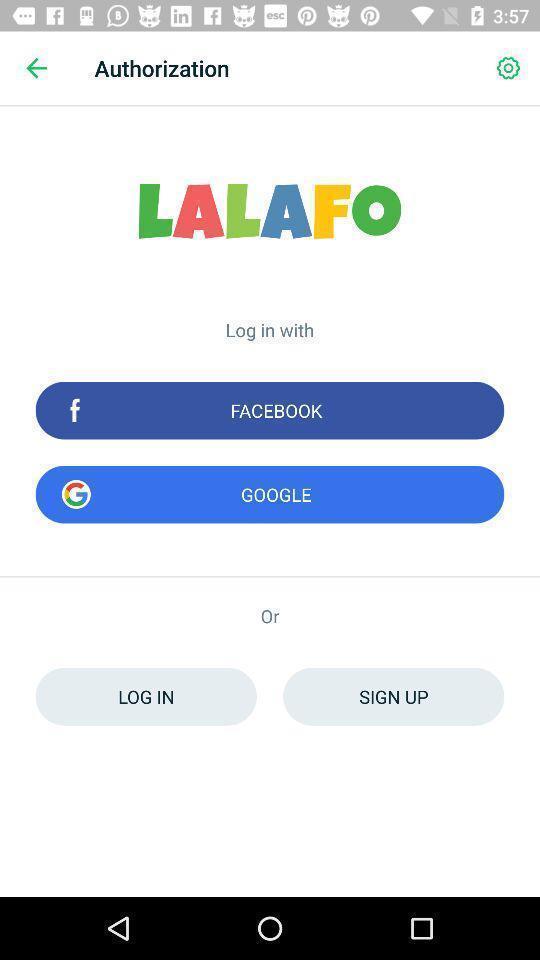Describe the key features of this screenshot. Page displaying to login via different networks. 